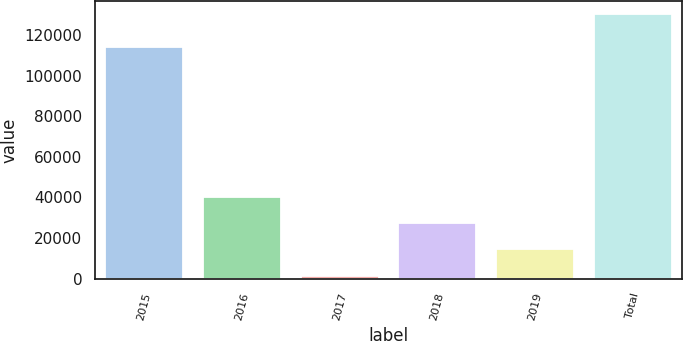Convert chart. <chart><loc_0><loc_0><loc_500><loc_500><bar_chart><fcel>2015<fcel>2016<fcel>2017<fcel>2018<fcel>2019<fcel>Total<nl><fcel>113960<fcel>40096.1<fcel>1541<fcel>27244.4<fcel>14392.7<fcel>130058<nl></chart> 